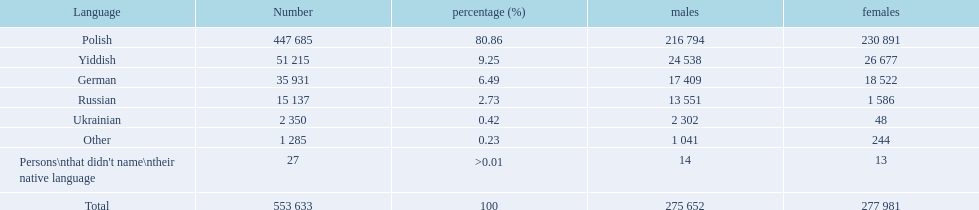What dialects are present? Polish, Yiddish, German, Russian, Ukrainian. What figures communicate in these dialects? 447 685, 51 215, 35 931, 15 137, 2 350. What figures are not recorded as communicating in these dialects? 1 285, 27. What are the aggregate of these speakers? 553 633. 